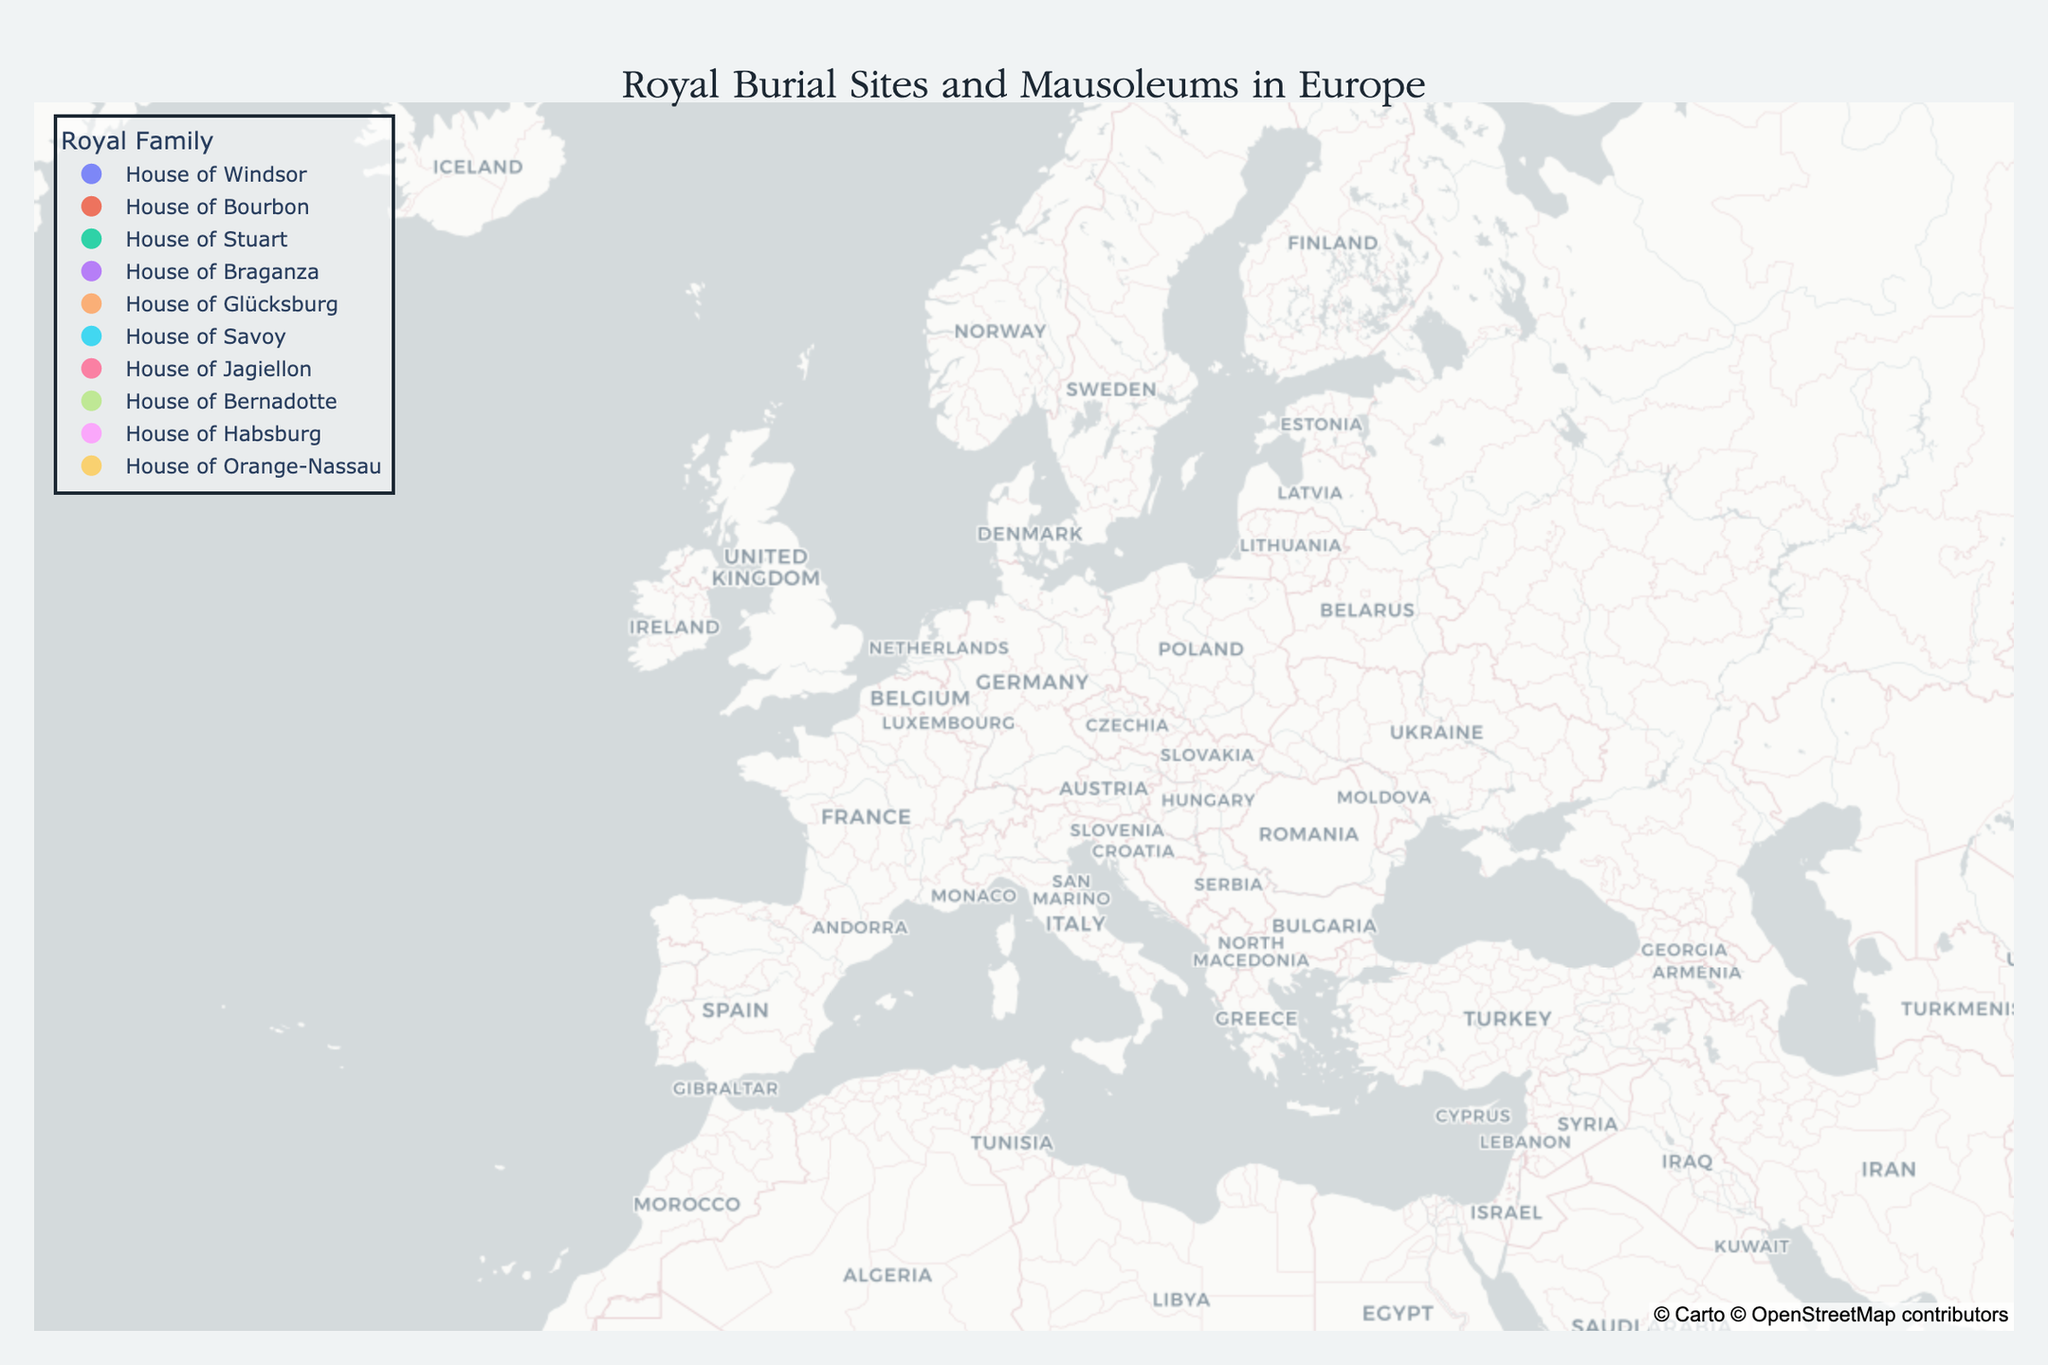What is the title of the figure? The title is usually positioned at the top of the figure. In this case, it's found in the layout settings of the plot.
Answer: "Royal Burial Sites and Mausoleums in Europe" How many royal burial sites are there in the figure? Each point in the scatter plot represents a burial site. Counting these points gives you the total number.
Answer: 11 Which country has the most royal burial sites listed in the figure? Look for the labels on each data point to check the countries. The United Kingdom appears twice.
Answer: United Kingdom Which royal family has burial sites in multiple countries? Check the "Royal Family" label for each site and note which ones appear in more than one country. The House of Bourbon appears in both France and Spain.
Answer: House of Bourbon What is the earliest year of the royal burial site listed? Find the "Year" label for each data point and identify the earliest year. Westminster Abbey is listed with the year 1066.
Answer: 1066 Which royal burial site is located at the highest latitude? Compare the latitude values of all the points. The highest latitude is 59.9170, corresponding to Akershus Fortress in Norway.
Answer: Akershus Fortress What is the average year of the royal burial sites? Sum the years provided for each burial site and divide by the number of sites, i.e., (1066 + 1144 + 1128 + 1629 + 1300 + 1878 + 1320 + 1290 + 1344 + 1584 + 1408) / 11. The total sum is 15091, so: 15091 / 11 = 1371
Answer: 1371 Which royal burial site is the newest in terms of the year listed? Identify the highest value in the "Year" column. The Pantheon in Italy, listed with the year 1878, is the newest.
Answer: Pantheon What is the southernmost location of a royal burial site in the figure? Compare the latitude values of all sites and identify the lowest value. São Vicente de Fora in Portugal is the southernmost at latitude 38.7122.
Answer: São Vicente de Fora Which burial site is located at approximately the midpoint latitude and longitude of all sites combined? Calculate the midpoint by averaging the latitudes and longitudes separately, i.e., (51.4995 + 48.8506 + 55.9533 + 38.7122 + 59.9170 + 41.9029 + 52.1732 + 59.3293 + 50.0755 + 40.4168 + 52.4025)/11 for latitude and (-0.1431 + 2.3522 - 3.1884 - 9.1313 + 10.7274 + 12.4534 + 20.9798 + 18.0686 + 14.4378 - 3.7038 + 4.8922)/11 for longitude: Midpoint latitude is 48.61895 and longitude is 6.7176, closest to Basilica of Saint-Denis.
Answer: Basilica of Saint-Denis 